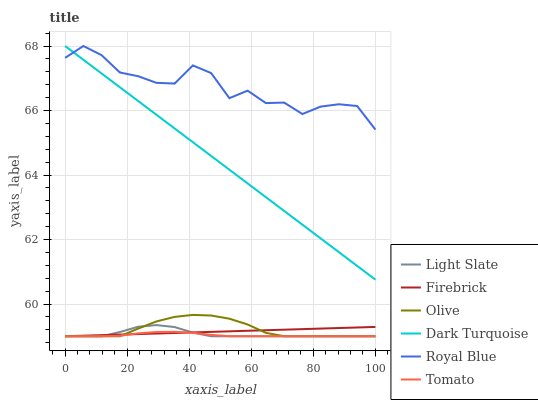Does Tomato have the minimum area under the curve?
Answer yes or no. Yes. Does Royal Blue have the maximum area under the curve?
Answer yes or no. Yes. Does Light Slate have the minimum area under the curve?
Answer yes or no. No. Does Light Slate have the maximum area under the curve?
Answer yes or no. No. Is Firebrick the smoothest?
Answer yes or no. Yes. Is Royal Blue the roughest?
Answer yes or no. Yes. Is Light Slate the smoothest?
Answer yes or no. No. Is Light Slate the roughest?
Answer yes or no. No. Does Tomato have the lowest value?
Answer yes or no. Yes. Does Dark Turquoise have the lowest value?
Answer yes or no. No. Does Royal Blue have the highest value?
Answer yes or no. Yes. Does Light Slate have the highest value?
Answer yes or no. No. Is Light Slate less than Royal Blue?
Answer yes or no. Yes. Is Royal Blue greater than Light Slate?
Answer yes or no. Yes. Does Firebrick intersect Tomato?
Answer yes or no. Yes. Is Firebrick less than Tomato?
Answer yes or no. No. Is Firebrick greater than Tomato?
Answer yes or no. No. Does Light Slate intersect Royal Blue?
Answer yes or no. No. 